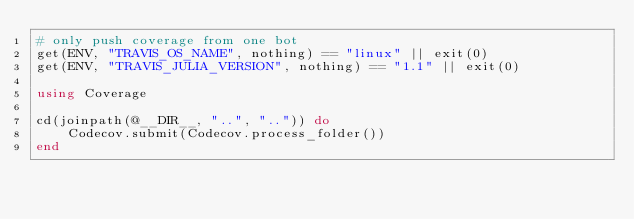Convert code to text. <code><loc_0><loc_0><loc_500><loc_500><_Julia_># only push coverage from one bot
get(ENV, "TRAVIS_OS_NAME", nothing) == "linux" || exit(0)
get(ENV, "TRAVIS_JULIA_VERSION", nothing) == "1.1" || exit(0)

using Coverage

cd(joinpath(@__DIR__, "..", "..")) do
    Codecov.submit(Codecov.process_folder())
end
</code> 